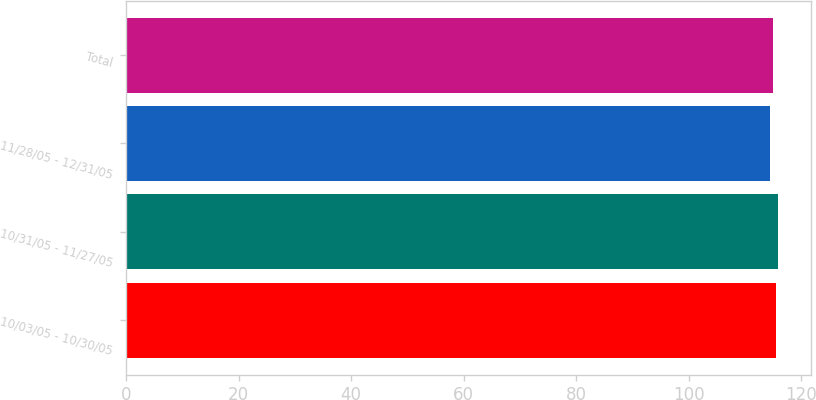<chart> <loc_0><loc_0><loc_500><loc_500><bar_chart><fcel>10/03/05 - 10/30/05<fcel>10/31/05 - 11/27/05<fcel>11/28/05 - 12/31/05<fcel>Total<nl><fcel>115.5<fcel>115.9<fcel>114.41<fcel>115.01<nl></chart> 